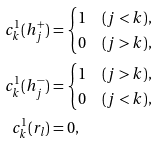Convert formula to latex. <formula><loc_0><loc_0><loc_500><loc_500>c ^ { 1 } _ { k } ( h ^ { + } _ { j } ) & = \begin{cases} 1 & ( j < k ) , \\ 0 & ( j > k ) , \end{cases} \\ c ^ { 1 } _ { k } ( h ^ { - } _ { j } ) & = \begin{cases} 1 & ( j > k ) , \\ 0 & ( j < k ) , \end{cases} \\ c ^ { 1 } _ { k } ( r _ { l } ) & = 0 ,</formula> 